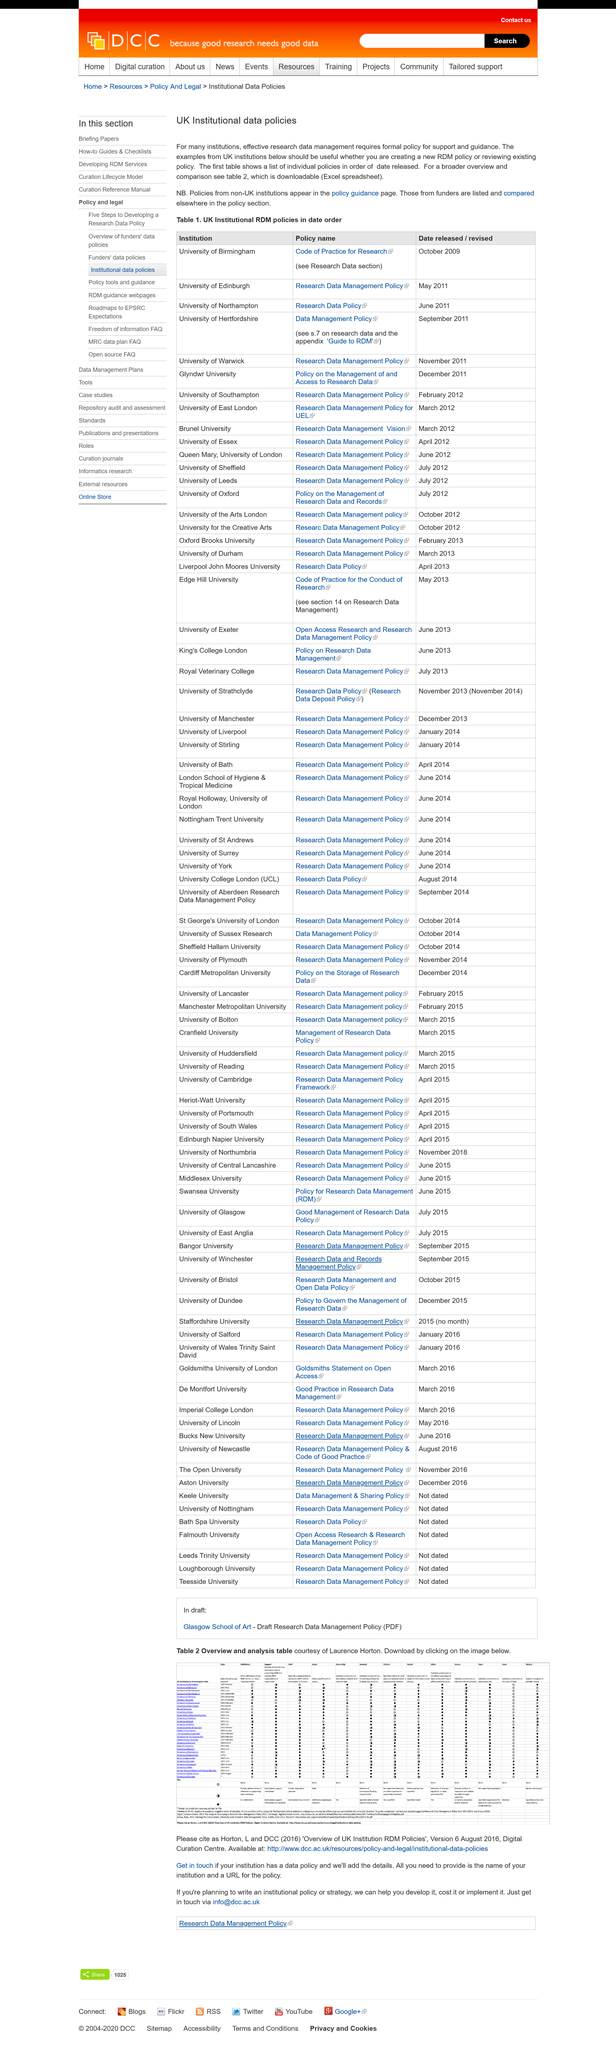Draw attention to some important aspects in this diagram. The overview is available on Excel. This page is dedicated to UK Institutional data policies. The title of the page is 'UK Institutional Data Policies'. 